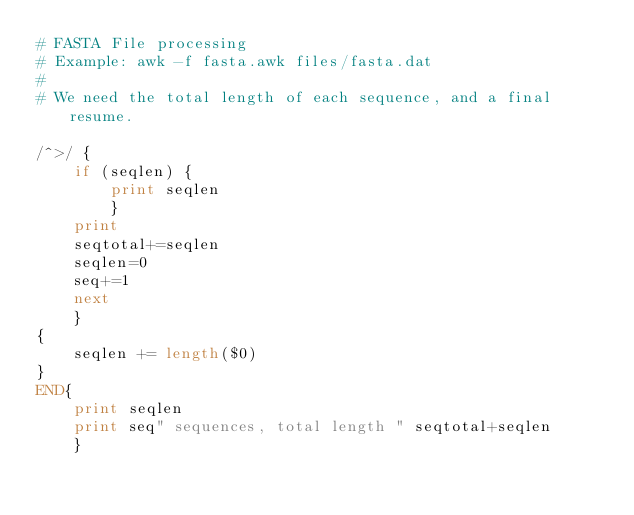<code> <loc_0><loc_0><loc_500><loc_500><_Awk_># FASTA File processing
# Example: awk -f fasta.awk files/fasta.dat 
#
# We need the total length of each sequence, and a final resume.

/^>/ {
    if (seqlen) {
        print seqlen
        }
    print
    seqtotal+=seqlen
    seqlen=0
    seq+=1
    next
    }
{
    seqlen += length($0)
}
END{
    print seqlen
    print seq" sequences, total length " seqtotal+seqlen
    }</code> 